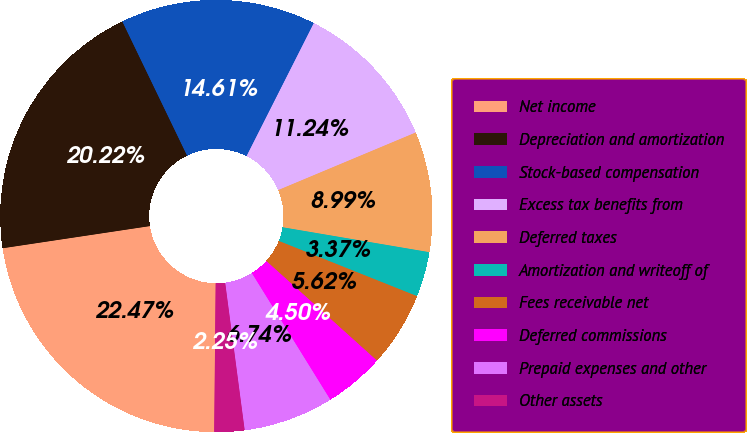<chart> <loc_0><loc_0><loc_500><loc_500><pie_chart><fcel>Net income<fcel>Depreciation and amortization<fcel>Stock-based compensation<fcel>Excess tax benefits from<fcel>Deferred taxes<fcel>Amortization and writeoff of<fcel>Fees receivable net<fcel>Deferred commissions<fcel>Prepaid expenses and other<fcel>Other assets<nl><fcel>22.47%<fcel>20.22%<fcel>14.61%<fcel>11.24%<fcel>8.99%<fcel>3.37%<fcel>5.62%<fcel>4.5%<fcel>6.74%<fcel>2.25%<nl></chart> 